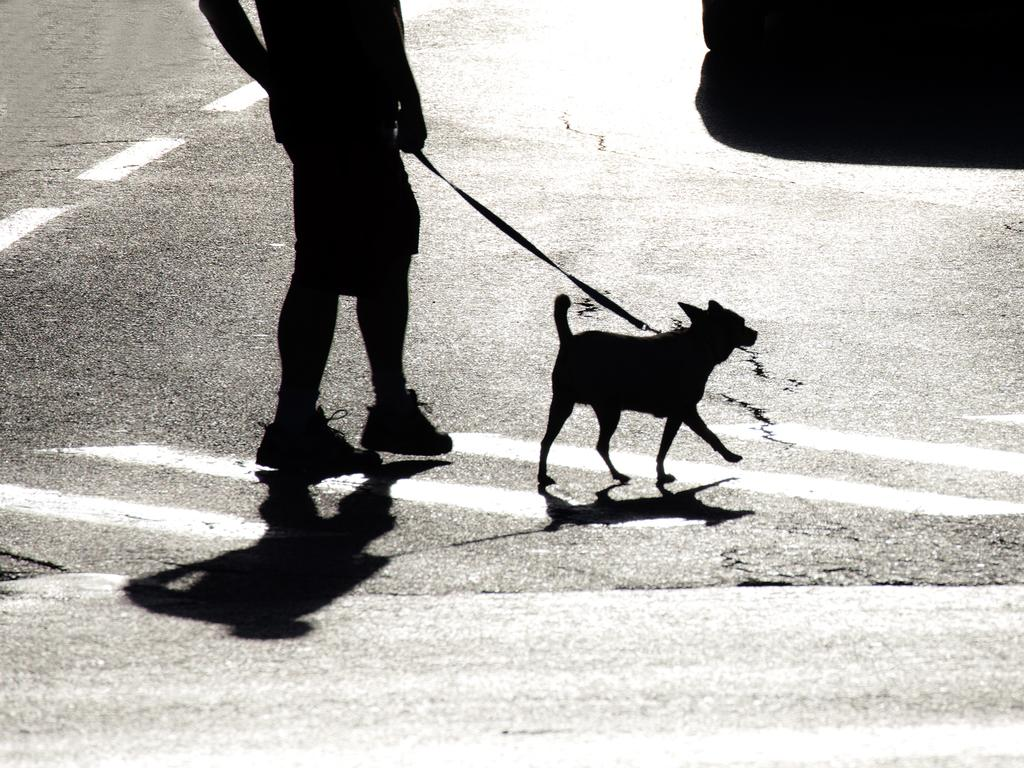Who is present in the image? There is a person in the image. What is the person holding? The person is holding a dog belt. What is the person doing in the image? The person is walking. Is there any other living creature in the image? Yes, there is a dog in the image. What is the dog doing in the image? The dog is also walking on the path. Where is the house located in the image? There is no house present in the image. Can you tell me how many bikes are visible in the image? There are no bikes visible in the image. 